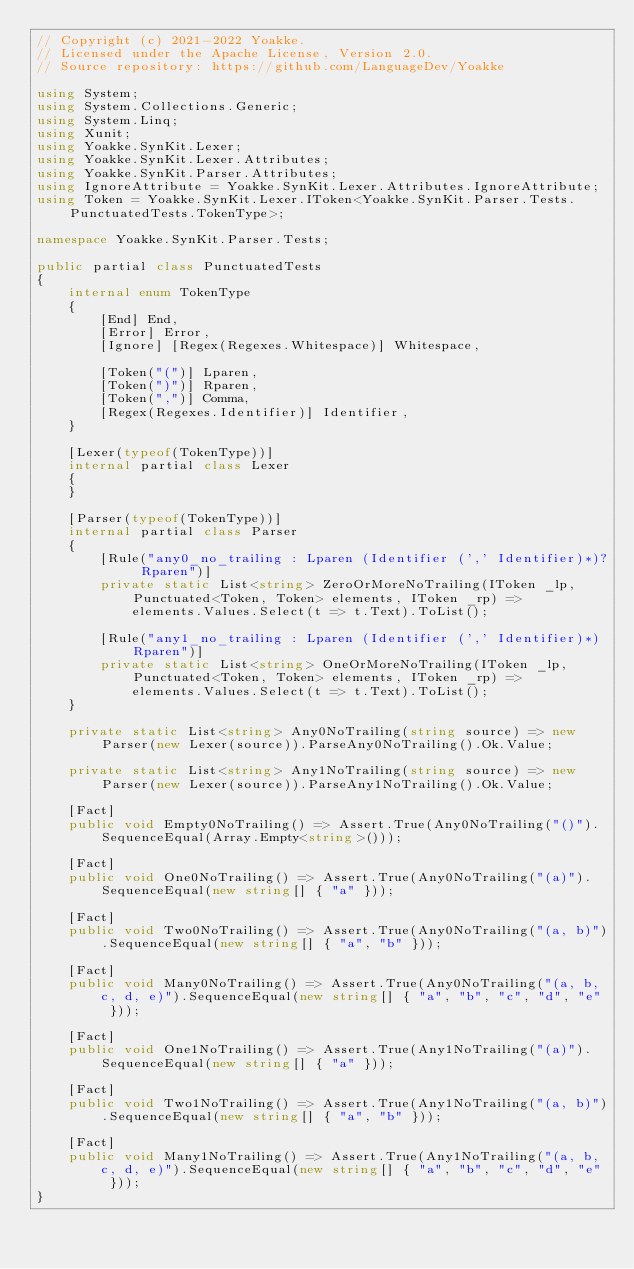Convert code to text. <code><loc_0><loc_0><loc_500><loc_500><_C#_>// Copyright (c) 2021-2022 Yoakke.
// Licensed under the Apache License, Version 2.0.
// Source repository: https://github.com/LanguageDev/Yoakke

using System;
using System.Collections.Generic;
using System.Linq;
using Xunit;
using Yoakke.SynKit.Lexer;
using Yoakke.SynKit.Lexer.Attributes;
using Yoakke.SynKit.Parser.Attributes;
using IgnoreAttribute = Yoakke.SynKit.Lexer.Attributes.IgnoreAttribute;
using Token = Yoakke.SynKit.Lexer.IToken<Yoakke.SynKit.Parser.Tests.PunctuatedTests.TokenType>;

namespace Yoakke.SynKit.Parser.Tests;

public partial class PunctuatedTests
{
    internal enum TokenType
    {
        [End] End,
        [Error] Error,
        [Ignore] [Regex(Regexes.Whitespace)] Whitespace,

        [Token("(")] Lparen,
        [Token(")")] Rparen,
        [Token(",")] Comma,
        [Regex(Regexes.Identifier)] Identifier,
    }

    [Lexer(typeof(TokenType))]
    internal partial class Lexer
    {
    }

    [Parser(typeof(TokenType))]
    internal partial class Parser
    {
        [Rule("any0_no_trailing : Lparen (Identifier (',' Identifier)*)? Rparen")]
        private static List<string> ZeroOrMoreNoTrailing(IToken _lp, Punctuated<Token, Token> elements, IToken _rp) =>
            elements.Values.Select(t => t.Text).ToList();

        [Rule("any1_no_trailing : Lparen (Identifier (',' Identifier)*) Rparen")]
        private static List<string> OneOrMoreNoTrailing(IToken _lp, Punctuated<Token, Token> elements, IToken _rp) =>
            elements.Values.Select(t => t.Text).ToList();
    }

    private static List<string> Any0NoTrailing(string source) => new Parser(new Lexer(source)).ParseAny0NoTrailing().Ok.Value;

    private static List<string> Any1NoTrailing(string source) => new Parser(new Lexer(source)).ParseAny1NoTrailing().Ok.Value;

    [Fact]
    public void Empty0NoTrailing() => Assert.True(Any0NoTrailing("()").SequenceEqual(Array.Empty<string>()));

    [Fact]
    public void One0NoTrailing() => Assert.True(Any0NoTrailing("(a)").SequenceEqual(new string[] { "a" }));

    [Fact]
    public void Two0NoTrailing() => Assert.True(Any0NoTrailing("(a, b)").SequenceEqual(new string[] { "a", "b" }));

    [Fact]
    public void Many0NoTrailing() => Assert.True(Any0NoTrailing("(a, b, c, d, e)").SequenceEqual(new string[] { "a", "b", "c", "d", "e" }));

    [Fact]
    public void One1NoTrailing() => Assert.True(Any1NoTrailing("(a)").SequenceEqual(new string[] { "a" }));

    [Fact]
    public void Two1NoTrailing() => Assert.True(Any1NoTrailing("(a, b)").SequenceEqual(new string[] { "a", "b" }));

    [Fact]
    public void Many1NoTrailing() => Assert.True(Any1NoTrailing("(a, b, c, d, e)").SequenceEqual(new string[] { "a", "b", "c", "d", "e" }));
}
</code> 